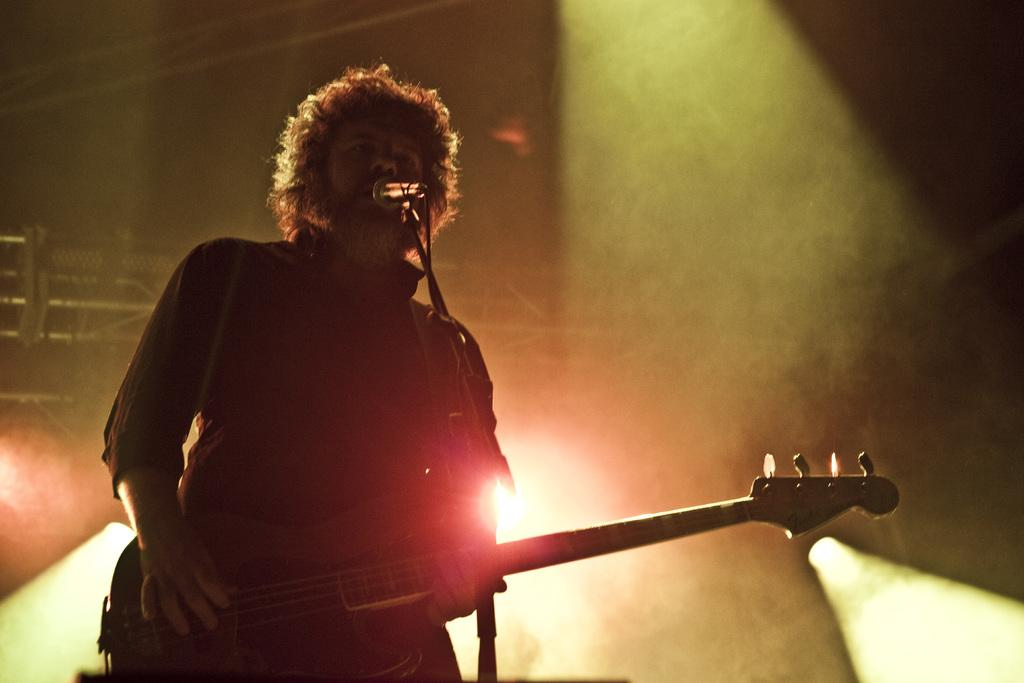What is the person on the stage doing? The person is playing the guitar. What is the person holding while on stage? The person is holding a guitar. What is the position of the person on the stage? The person is standing. What can be seen behind the person on stage? Lights are located behind the person. What time of day is it in the image, considering the person is wearing a shirt? The image does not provide information about the time of day or the person's clothing, so it cannot be determined from the image. 